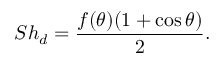<formula> <loc_0><loc_0><loc_500><loc_500>S h _ { d } = \frac { f ( \theta ) ( 1 + \cos \theta ) } { 2 } .</formula> 